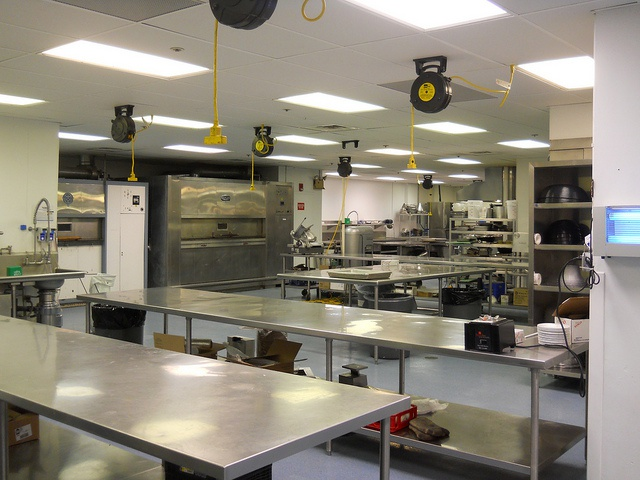Describe the objects in this image and their specific colors. I can see dining table in gray, darkgray, and tan tones, refrigerator in gray, black, darkgreen, and olive tones, refrigerator in gray, lightgray, tan, and darkgray tones, bowl in gray and black tones, and sink in gray, darkgreen, and tan tones in this image. 